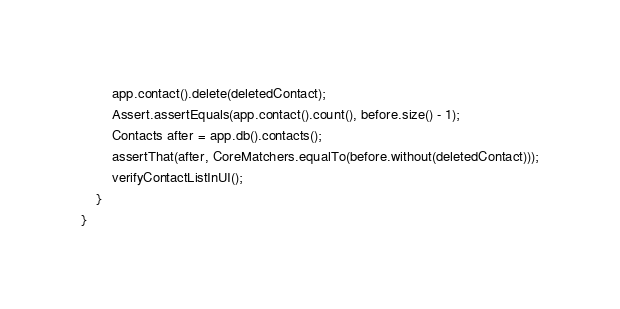<code> <loc_0><loc_0><loc_500><loc_500><_Java_>        app.contact().delete(deletedContact);
        Assert.assertEquals(app.contact().count(), before.size() - 1);
        Contacts after = app.db().contacts();
        assertThat(after, CoreMatchers.equalTo(before.without(deletedContact)));
        verifyContactListInUI();
    }
}

</code> 